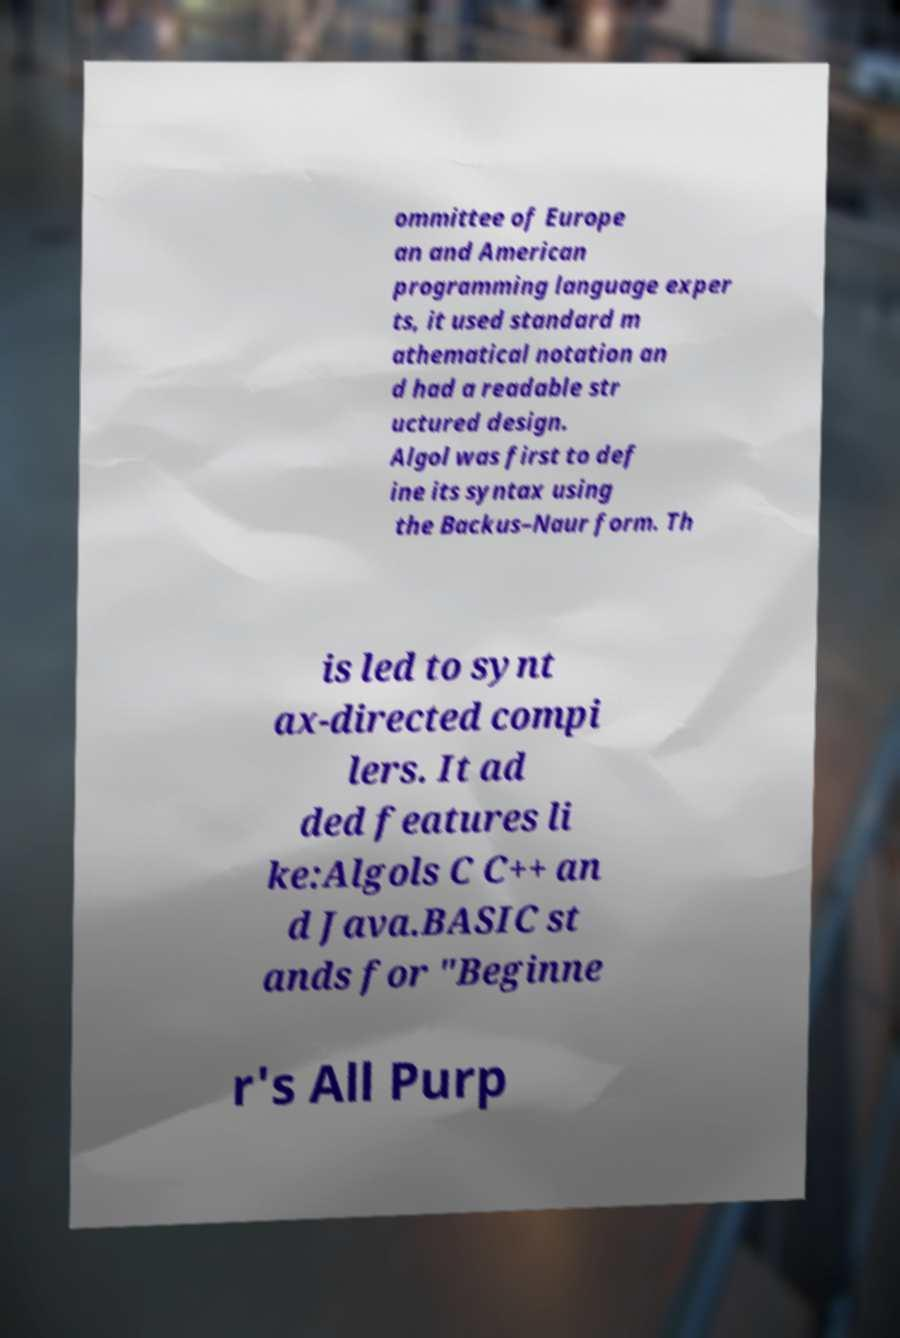There's text embedded in this image that I need extracted. Can you transcribe it verbatim? ommittee of Europe an and American programming language exper ts, it used standard m athematical notation an d had a readable str uctured design. Algol was first to def ine its syntax using the Backus–Naur form. Th is led to synt ax-directed compi lers. It ad ded features li ke:Algols C C++ an d Java.BASIC st ands for "Beginne r's All Purp 